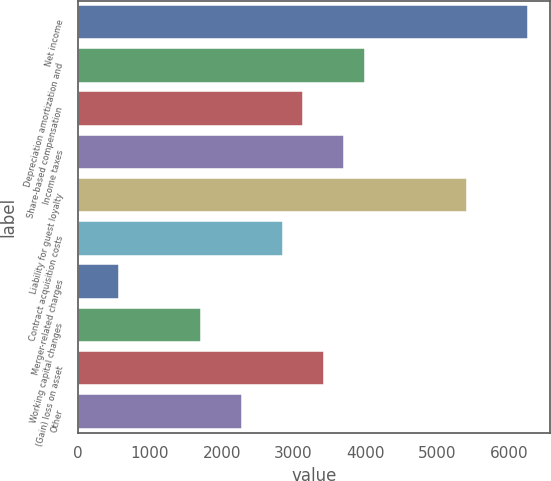<chart> <loc_0><loc_0><loc_500><loc_500><bar_chart><fcel>Net income<fcel>Depreciation amortization and<fcel>Share-based compensation<fcel>Income taxes<fcel>Liability for guest loyalty<fcel>Contract acquisition costs<fcel>Merger-related charges<fcel>Working capital changes<fcel>(Gain) loss on asset<fcel>Other<nl><fcel>6265.2<fcel>3988.4<fcel>3134.6<fcel>3703.8<fcel>5411.4<fcel>2850<fcel>573.2<fcel>1711.6<fcel>3419.2<fcel>2280.8<nl></chart> 